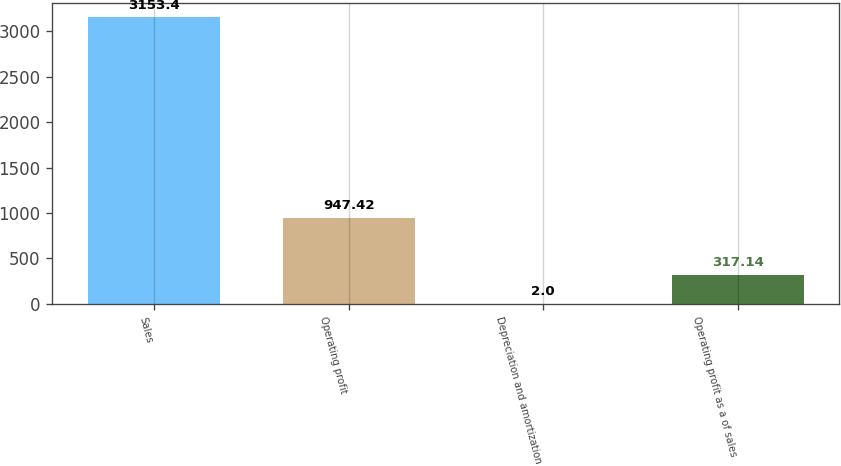Convert chart to OTSL. <chart><loc_0><loc_0><loc_500><loc_500><bar_chart><fcel>Sales<fcel>Operating profit<fcel>Depreciation and amortization<fcel>Operating profit as a of sales<nl><fcel>3153.4<fcel>947.42<fcel>2<fcel>317.14<nl></chart> 